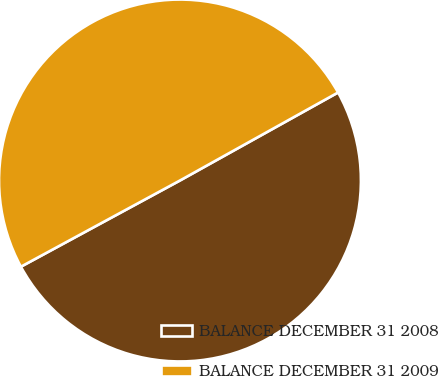Convert chart. <chart><loc_0><loc_0><loc_500><loc_500><pie_chart><fcel>BALANCE DECEMBER 31 2008<fcel>BALANCE DECEMBER 31 2009<nl><fcel>50.18%<fcel>49.82%<nl></chart> 